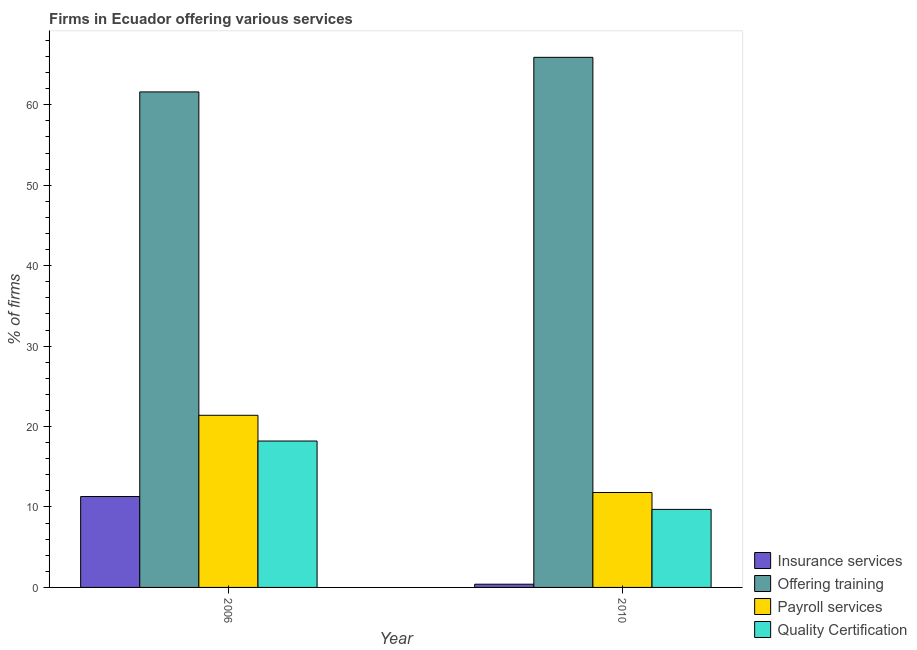How many different coloured bars are there?
Provide a short and direct response. 4. Are the number of bars on each tick of the X-axis equal?
Ensure brevity in your answer.  Yes. How many bars are there on the 2nd tick from the right?
Ensure brevity in your answer.  4. What is the label of the 2nd group of bars from the left?
Keep it short and to the point. 2010. In how many cases, is the number of bars for a given year not equal to the number of legend labels?
Make the answer very short. 0. What is the percentage of firms offering insurance services in 2010?
Your response must be concise. 0.4. Across all years, what is the maximum percentage of firms offering quality certification?
Your response must be concise. 18.2. Across all years, what is the minimum percentage of firms offering payroll services?
Your answer should be compact. 11.8. In which year was the percentage of firms offering insurance services maximum?
Your response must be concise. 2006. In which year was the percentage of firms offering quality certification minimum?
Give a very brief answer. 2010. What is the total percentage of firms offering payroll services in the graph?
Your answer should be compact. 33.2. What is the difference between the percentage of firms offering insurance services in 2010 and the percentage of firms offering training in 2006?
Keep it short and to the point. -10.9. In how many years, is the percentage of firms offering insurance services greater than 60 %?
Make the answer very short. 0. What is the ratio of the percentage of firms offering payroll services in 2006 to that in 2010?
Your response must be concise. 1.81. Is the percentage of firms offering quality certification in 2006 less than that in 2010?
Keep it short and to the point. No. In how many years, is the percentage of firms offering training greater than the average percentage of firms offering training taken over all years?
Provide a succinct answer. 1. Is it the case that in every year, the sum of the percentage of firms offering payroll services and percentage of firms offering quality certification is greater than the sum of percentage of firms offering training and percentage of firms offering insurance services?
Make the answer very short. No. What does the 4th bar from the left in 2010 represents?
Provide a succinct answer. Quality Certification. What does the 2nd bar from the right in 2006 represents?
Your response must be concise. Payroll services. How many legend labels are there?
Make the answer very short. 4. What is the title of the graph?
Keep it short and to the point. Firms in Ecuador offering various services . Does "International Development Association" appear as one of the legend labels in the graph?
Provide a short and direct response. No. What is the label or title of the X-axis?
Offer a very short reply. Year. What is the label or title of the Y-axis?
Provide a succinct answer. % of firms. What is the % of firms in Insurance services in 2006?
Make the answer very short. 11.3. What is the % of firms in Offering training in 2006?
Offer a terse response. 61.6. What is the % of firms in Payroll services in 2006?
Offer a terse response. 21.4. What is the % of firms in Offering training in 2010?
Offer a very short reply. 65.9. What is the % of firms of Payroll services in 2010?
Ensure brevity in your answer.  11.8. Across all years, what is the maximum % of firms of Offering training?
Provide a short and direct response. 65.9. Across all years, what is the maximum % of firms in Payroll services?
Offer a very short reply. 21.4. Across all years, what is the minimum % of firms in Insurance services?
Provide a short and direct response. 0.4. Across all years, what is the minimum % of firms of Offering training?
Your answer should be very brief. 61.6. Across all years, what is the minimum % of firms of Payroll services?
Ensure brevity in your answer.  11.8. Across all years, what is the minimum % of firms in Quality Certification?
Give a very brief answer. 9.7. What is the total % of firms of Insurance services in the graph?
Your answer should be very brief. 11.7. What is the total % of firms of Offering training in the graph?
Provide a short and direct response. 127.5. What is the total % of firms in Payroll services in the graph?
Ensure brevity in your answer.  33.2. What is the total % of firms of Quality Certification in the graph?
Offer a terse response. 27.9. What is the difference between the % of firms of Offering training in 2006 and that in 2010?
Your answer should be very brief. -4.3. What is the difference between the % of firms of Insurance services in 2006 and the % of firms of Offering training in 2010?
Keep it short and to the point. -54.6. What is the difference between the % of firms in Insurance services in 2006 and the % of firms in Payroll services in 2010?
Offer a terse response. -0.5. What is the difference between the % of firms in Insurance services in 2006 and the % of firms in Quality Certification in 2010?
Offer a very short reply. 1.6. What is the difference between the % of firms in Offering training in 2006 and the % of firms in Payroll services in 2010?
Keep it short and to the point. 49.8. What is the difference between the % of firms of Offering training in 2006 and the % of firms of Quality Certification in 2010?
Your answer should be compact. 51.9. What is the average % of firms of Insurance services per year?
Ensure brevity in your answer.  5.85. What is the average % of firms of Offering training per year?
Keep it short and to the point. 63.75. What is the average % of firms of Payroll services per year?
Keep it short and to the point. 16.6. What is the average % of firms of Quality Certification per year?
Give a very brief answer. 13.95. In the year 2006, what is the difference between the % of firms in Insurance services and % of firms in Offering training?
Offer a very short reply. -50.3. In the year 2006, what is the difference between the % of firms in Insurance services and % of firms in Quality Certification?
Give a very brief answer. -6.9. In the year 2006, what is the difference between the % of firms of Offering training and % of firms of Payroll services?
Your answer should be very brief. 40.2. In the year 2006, what is the difference between the % of firms in Offering training and % of firms in Quality Certification?
Your response must be concise. 43.4. In the year 2010, what is the difference between the % of firms of Insurance services and % of firms of Offering training?
Ensure brevity in your answer.  -65.5. In the year 2010, what is the difference between the % of firms of Insurance services and % of firms of Payroll services?
Offer a very short reply. -11.4. In the year 2010, what is the difference between the % of firms in Offering training and % of firms in Payroll services?
Provide a short and direct response. 54.1. In the year 2010, what is the difference between the % of firms in Offering training and % of firms in Quality Certification?
Your answer should be very brief. 56.2. In the year 2010, what is the difference between the % of firms of Payroll services and % of firms of Quality Certification?
Make the answer very short. 2.1. What is the ratio of the % of firms in Insurance services in 2006 to that in 2010?
Give a very brief answer. 28.25. What is the ratio of the % of firms of Offering training in 2006 to that in 2010?
Make the answer very short. 0.93. What is the ratio of the % of firms in Payroll services in 2006 to that in 2010?
Give a very brief answer. 1.81. What is the ratio of the % of firms of Quality Certification in 2006 to that in 2010?
Keep it short and to the point. 1.88. What is the difference between the highest and the second highest % of firms in Quality Certification?
Keep it short and to the point. 8.5. What is the difference between the highest and the lowest % of firms of Insurance services?
Keep it short and to the point. 10.9. 